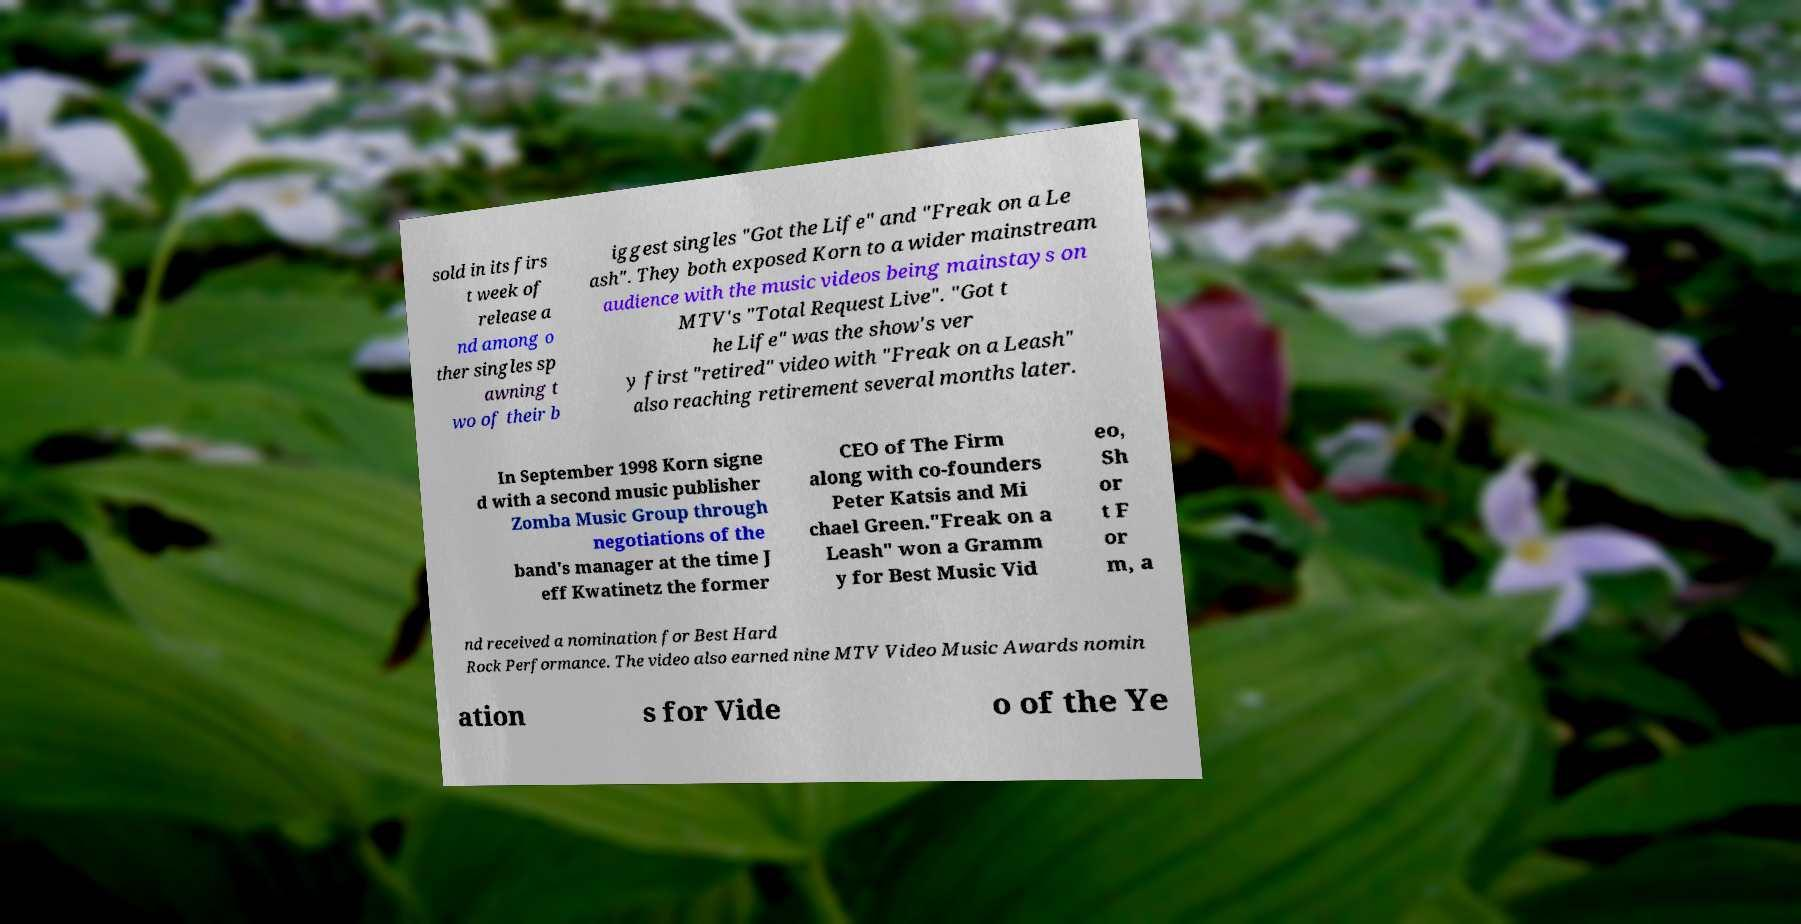There's text embedded in this image that I need extracted. Can you transcribe it verbatim? sold in its firs t week of release a nd among o ther singles sp awning t wo of their b iggest singles "Got the Life" and "Freak on a Le ash". They both exposed Korn to a wider mainstream audience with the music videos being mainstays on MTV's "Total Request Live". "Got t he Life" was the show's ver y first "retired" video with "Freak on a Leash" also reaching retirement several months later. In September 1998 Korn signe d with a second music publisher Zomba Music Group through negotiations of the band's manager at the time J eff Kwatinetz the former CEO of The Firm along with co-founders Peter Katsis and Mi chael Green."Freak on a Leash" won a Gramm y for Best Music Vid eo, Sh or t F or m, a nd received a nomination for Best Hard Rock Performance. The video also earned nine MTV Video Music Awards nomin ation s for Vide o of the Ye 